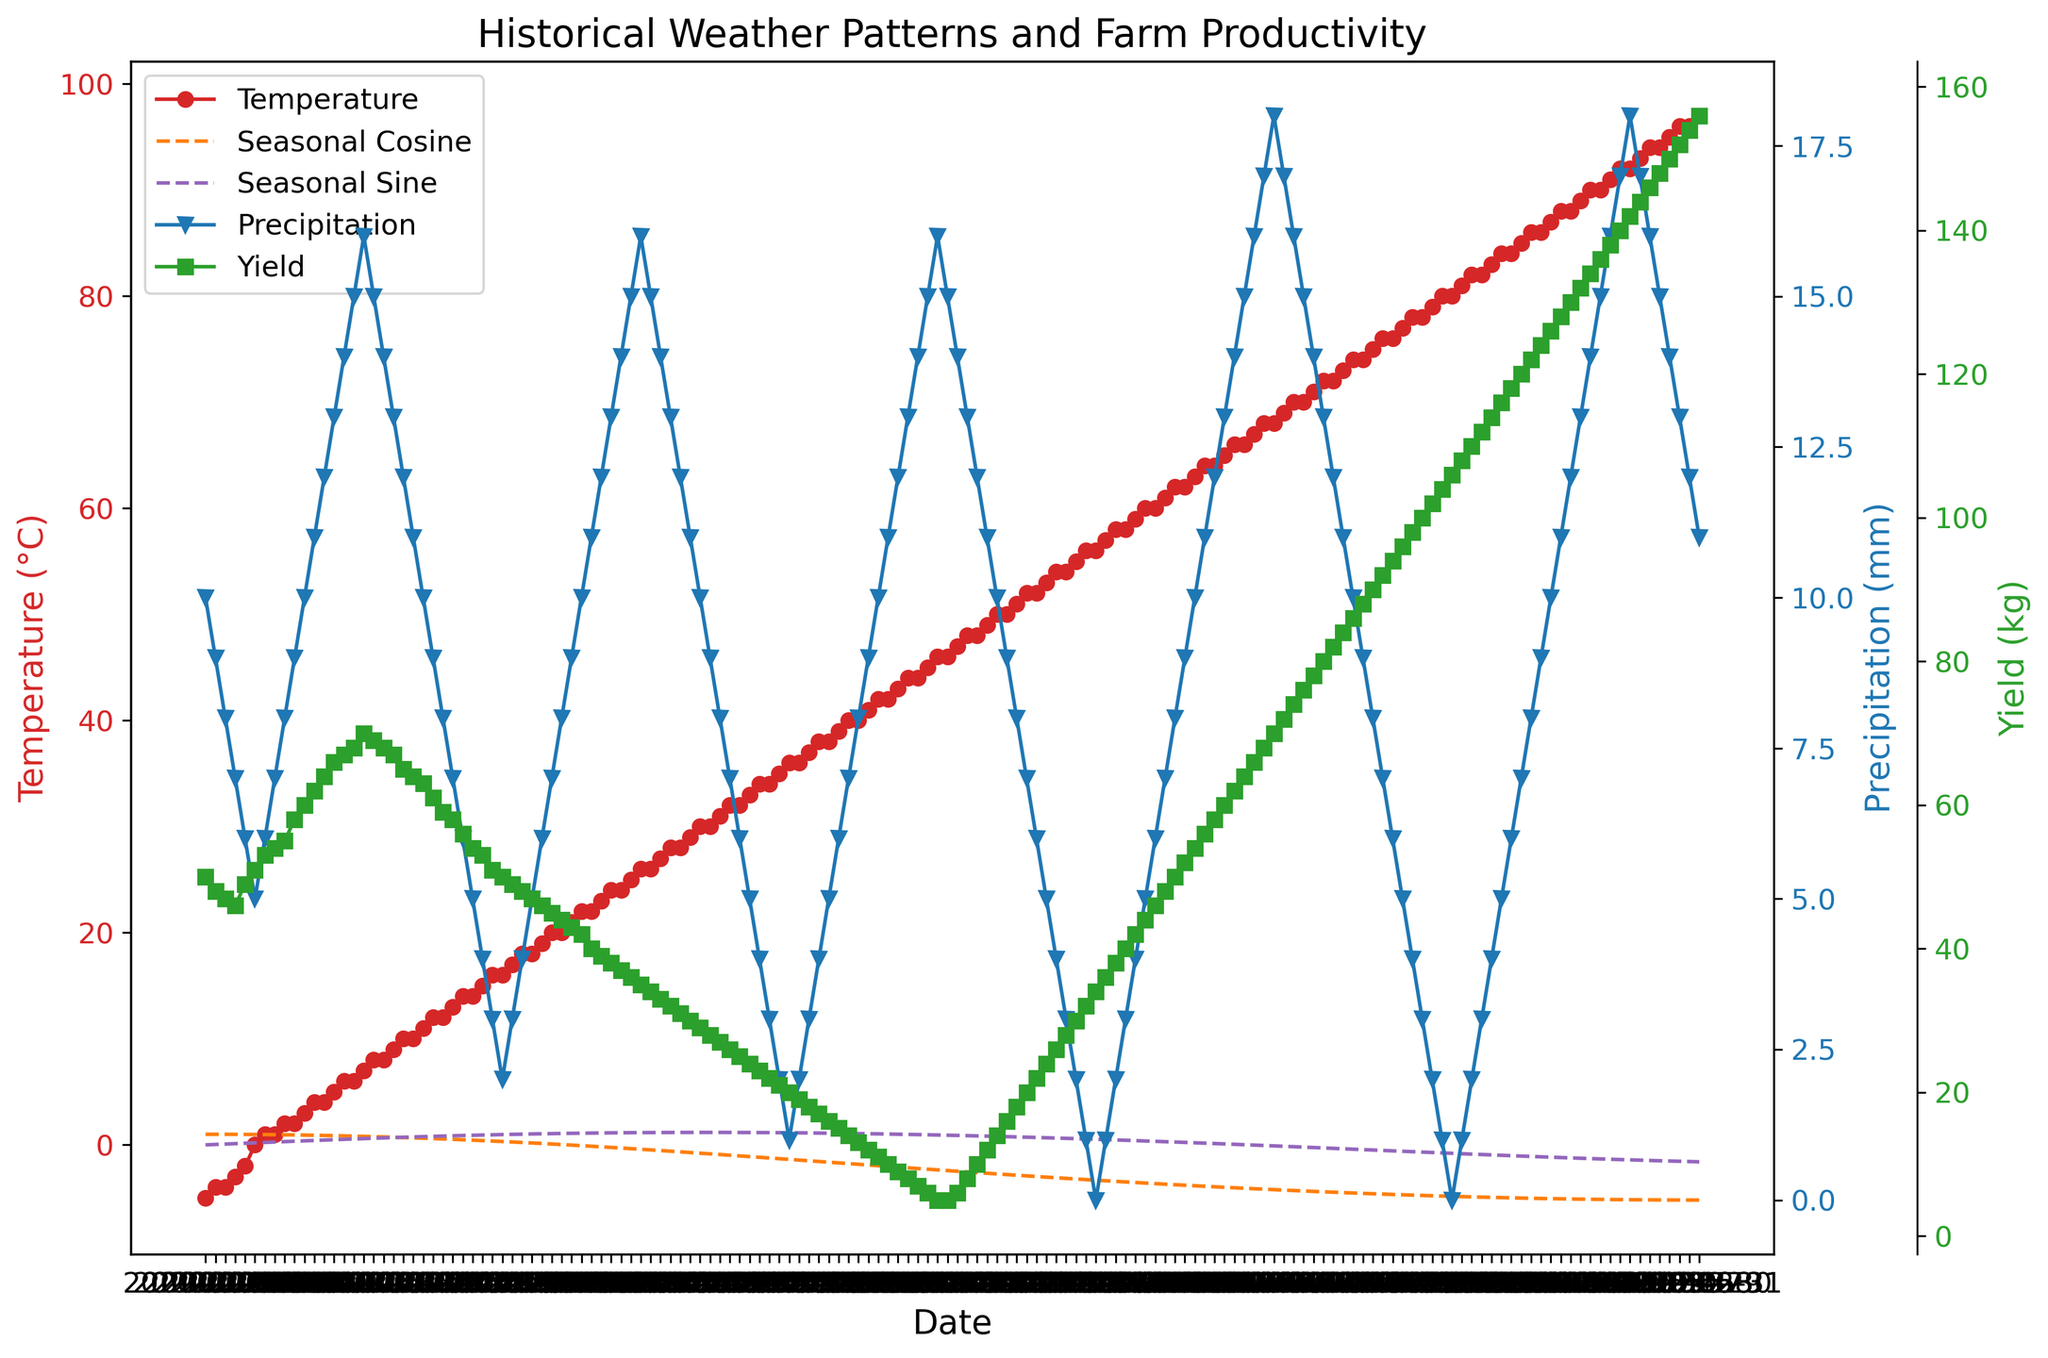What is the highest temperature recorded in the given time period? Look for the peak of the red temperature line in the figure. The highest point shows the maximum temperature recorded.
Answer: 97°C On which date did the yield reach its peak? Observe the green yield line and find the highest point. The corresponding date will be where this peak occurs.
Answer: May 31 How does the change in yield relate to temperature variations? Notice the relationship between the green yield line and the red temperature line. There’s a general upward trend in yield as the temperature increases up to a certain point, then it starts to decline when the temperature is consistently high.
Answer: Yield generally increases with temperature until it reaches a peak and then declines How does the cosine function visually correlate with the temperature? Compare the curve of the cosine function (orange dashed line) with the red temperature line. The peaks and troughs of the cosine function align with the seasonal trends in the temperature variation.
Answer: Peaks and troughs align in a seasonal pattern What is the range of precipitation values throughout the observed period? Identify the highest and lowest points of the blue precipitation line on the secondary y-axis. The maximum and minimum values represent the range.
Answer: 0 mm to 18 mm Which month shows the highest average yield, and what is that average yield? Visually break down the green yield line into monthly segments and estimate the average height of the points in each segment. The highest estimate represents the highest monthly average yield.
Answer: May, around 144 kg Is there a time of year that shows a distinct increase in both temperature and yield at the same time? Look for a period where both the green yield line and red temperature line show an upward trend simultaneously. This typically happens in late spring or early summer.
Answer: Late April to early May How do the sine values compare to the cosine values over time? Observe the purple sine line and the orange cosine line. Note the periods where their values are positive, negative, increasing, or decreasing. They are generally out of phase by 90 degrees.
Answer: Out of phase, 90 degrees What is the difference in yield between the start of February and the end of May? Find the yield values for February 1st and May 31st by following the green yield line on these dates. Subtract the former from the latter to get the difference.
Answer: 156 kg - 49 kg = 107 kg During what time frame does the precipitation value mostly remain constant? Look for a flat section of the blue precipitation line, indicating steady precipitation. A notable stretch of constant precipitation occurs around mid-May.
Answer: Mid-May 